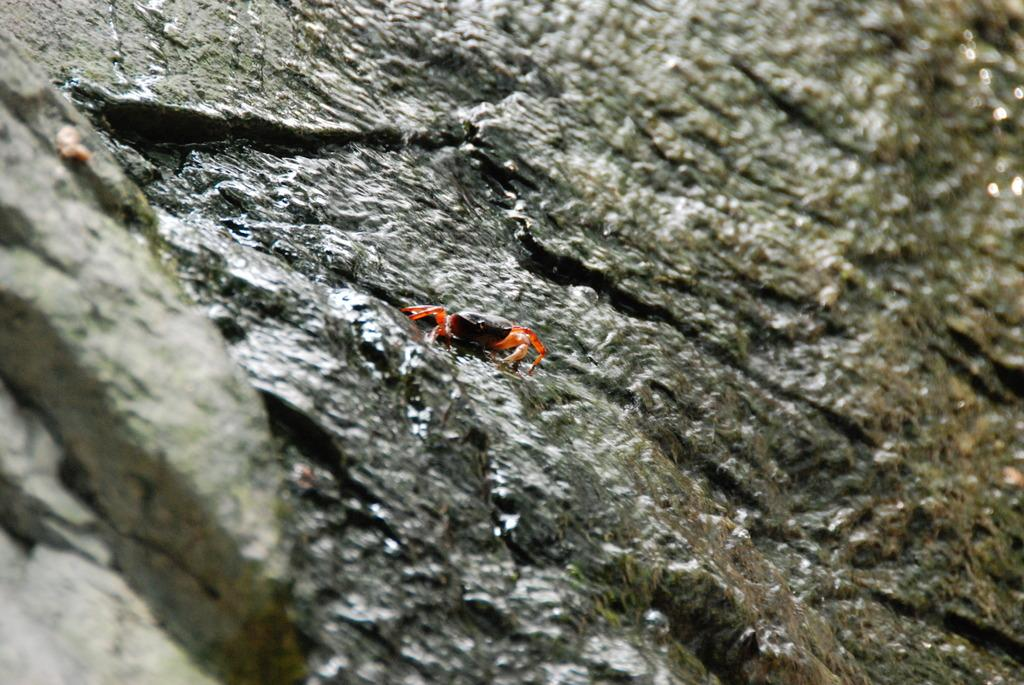What type of creature can be seen in the image? There is an insect in the image. Where is the insect located in the image? The insect is on a rock. What type of cheese is the insect eating in the image? There is no cheese present in the image, and the insect is not eating anything. Is the insect a character from a fictional story in the image? There is no indication in the image that the insect is a character from a fictional story. 